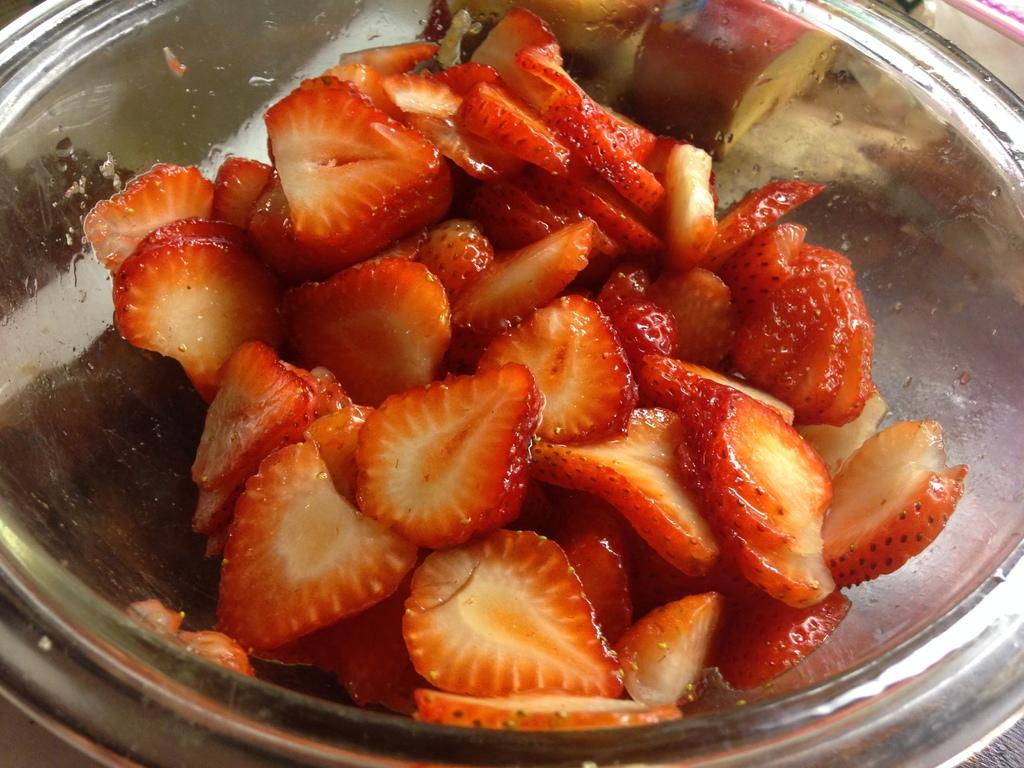What is in the bowl that is visible in the image? There is food in the bowl in the image. Can you describe the appearance of the food? The food has red and cream colors. What type of sweater is being worn by the food in the image? There is no sweater present in the image, as the subject is food in a bowl. 